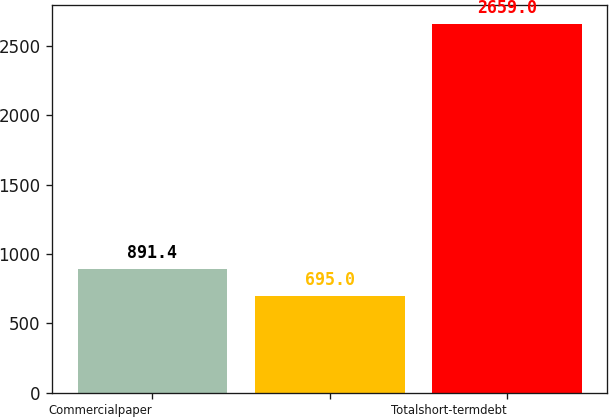Convert chart. <chart><loc_0><loc_0><loc_500><loc_500><bar_chart><fcel>Commercialpaper<fcel>Unnamed: 1<fcel>Totalshort-termdebt<nl><fcel>891.4<fcel>695<fcel>2659<nl></chart> 